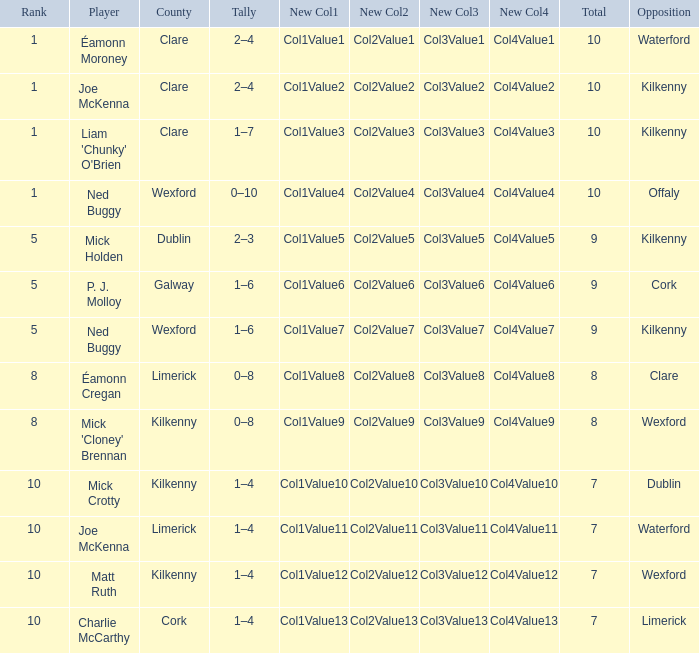Which County has a Rank larger than 8, and a Player of joe mckenna? Limerick. 